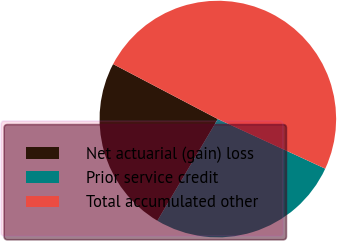Convert chart. <chart><loc_0><loc_0><loc_500><loc_500><pie_chart><fcel>Net actuarial (gain) loss<fcel>Prior service credit<fcel>Total accumulated other<nl><fcel>24.15%<fcel>26.65%<fcel>49.2%<nl></chart> 